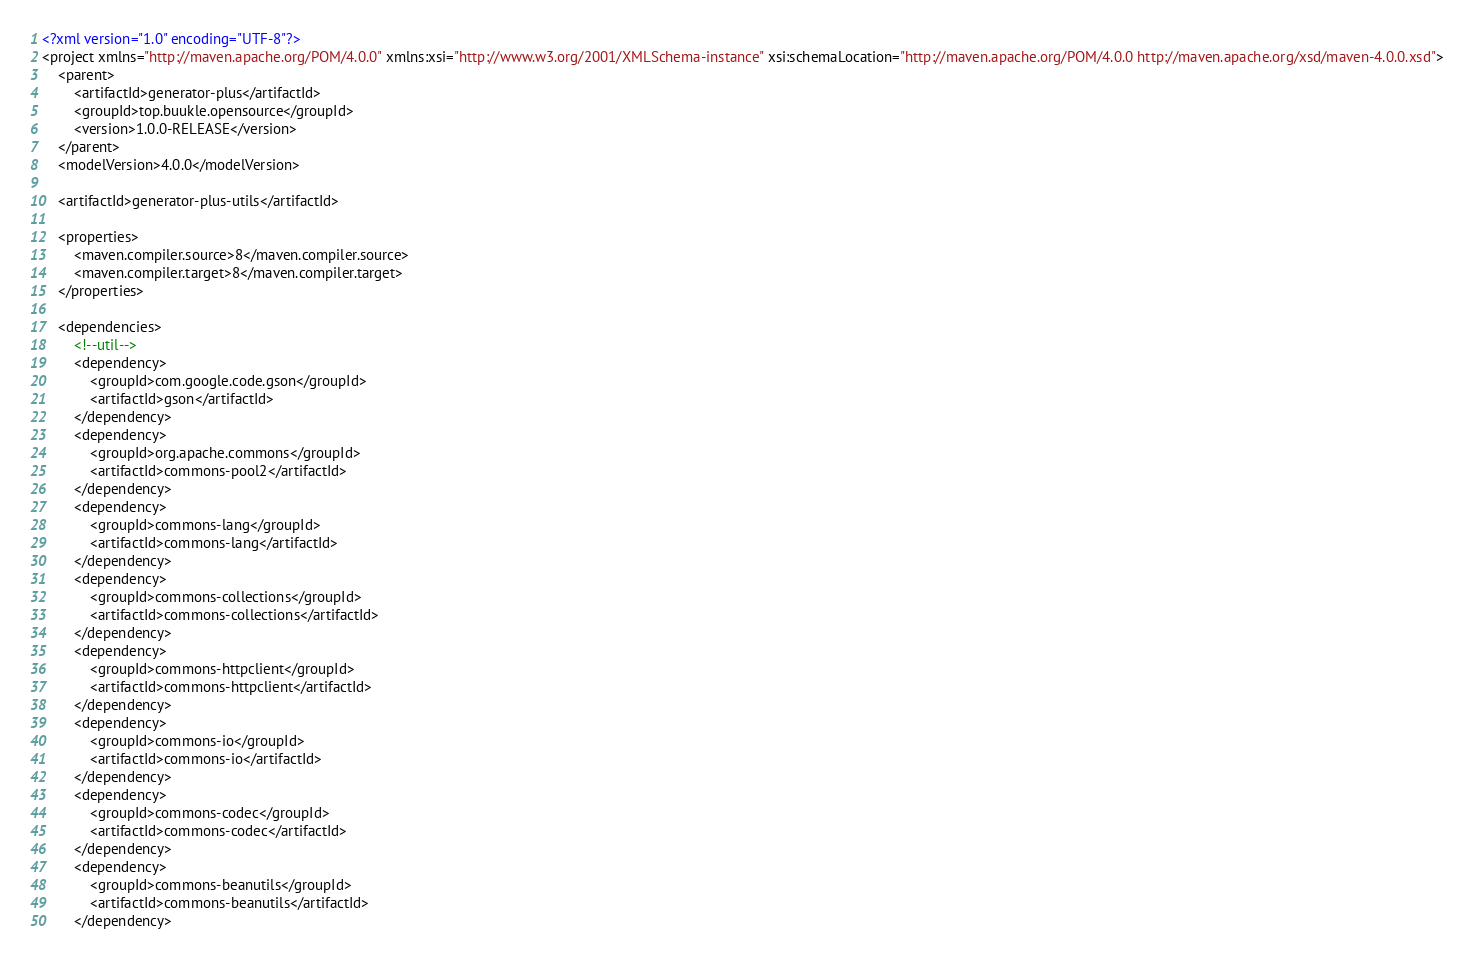Convert code to text. <code><loc_0><loc_0><loc_500><loc_500><_XML_><?xml version="1.0" encoding="UTF-8"?>
<project xmlns="http://maven.apache.org/POM/4.0.0" xmlns:xsi="http://www.w3.org/2001/XMLSchema-instance" xsi:schemaLocation="http://maven.apache.org/POM/4.0.0 http://maven.apache.org/xsd/maven-4.0.0.xsd">
    <parent>
        <artifactId>generator-plus</artifactId>
        <groupId>top.buukle.opensource</groupId>
        <version>1.0.0-RELEASE</version>
    </parent>
    <modelVersion>4.0.0</modelVersion>

    <artifactId>generator-plus-utils</artifactId>

    <properties>
        <maven.compiler.source>8</maven.compiler.source>
        <maven.compiler.target>8</maven.compiler.target>
    </properties>

    <dependencies>
        <!--util-->
        <dependency>
            <groupId>com.google.code.gson</groupId>
            <artifactId>gson</artifactId>
        </dependency>
        <dependency>
            <groupId>org.apache.commons</groupId>
            <artifactId>commons-pool2</artifactId>
        </dependency>
        <dependency>
            <groupId>commons-lang</groupId>
            <artifactId>commons-lang</artifactId>
        </dependency>
        <dependency>
            <groupId>commons-collections</groupId>
            <artifactId>commons-collections</artifactId>
        </dependency>
        <dependency>
            <groupId>commons-httpclient</groupId>
            <artifactId>commons-httpclient</artifactId>
        </dependency>
        <dependency>
            <groupId>commons-io</groupId>
            <artifactId>commons-io</artifactId>
        </dependency>
        <dependency>
            <groupId>commons-codec</groupId>
            <artifactId>commons-codec</artifactId>
        </dependency>
        <dependency>
            <groupId>commons-beanutils</groupId>
            <artifactId>commons-beanutils</artifactId>
        </dependency></code> 